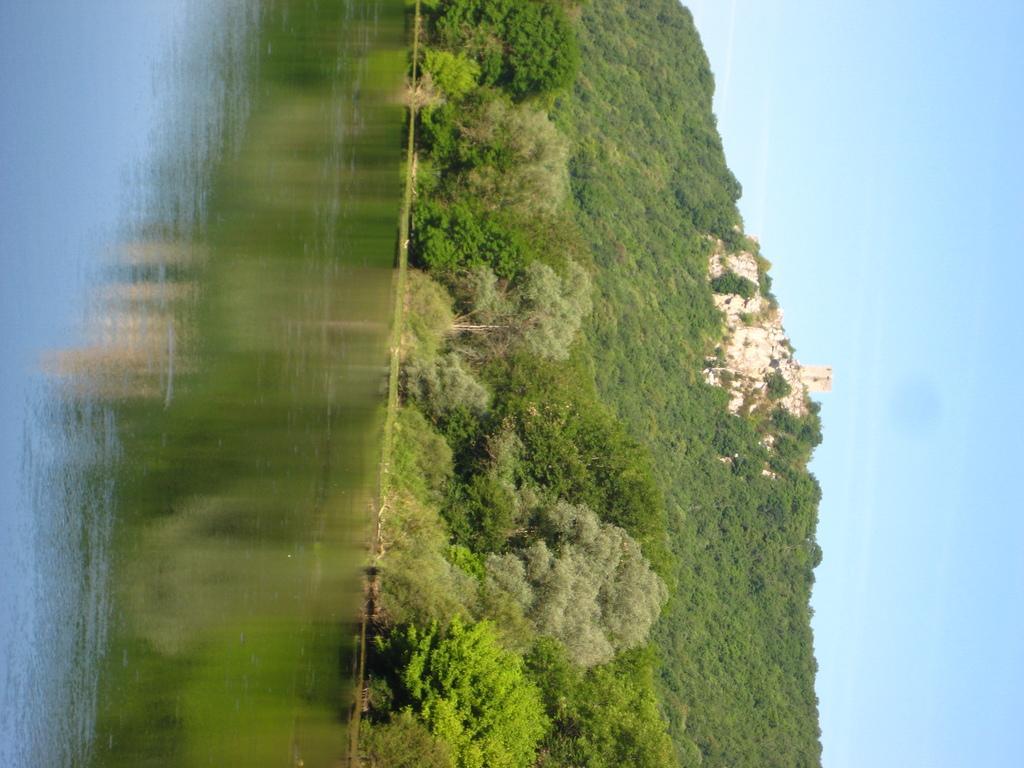In one or two sentences, can you explain what this image depicts? We can see water,trees,hill and sky. On the water we can see reflection of trees. 